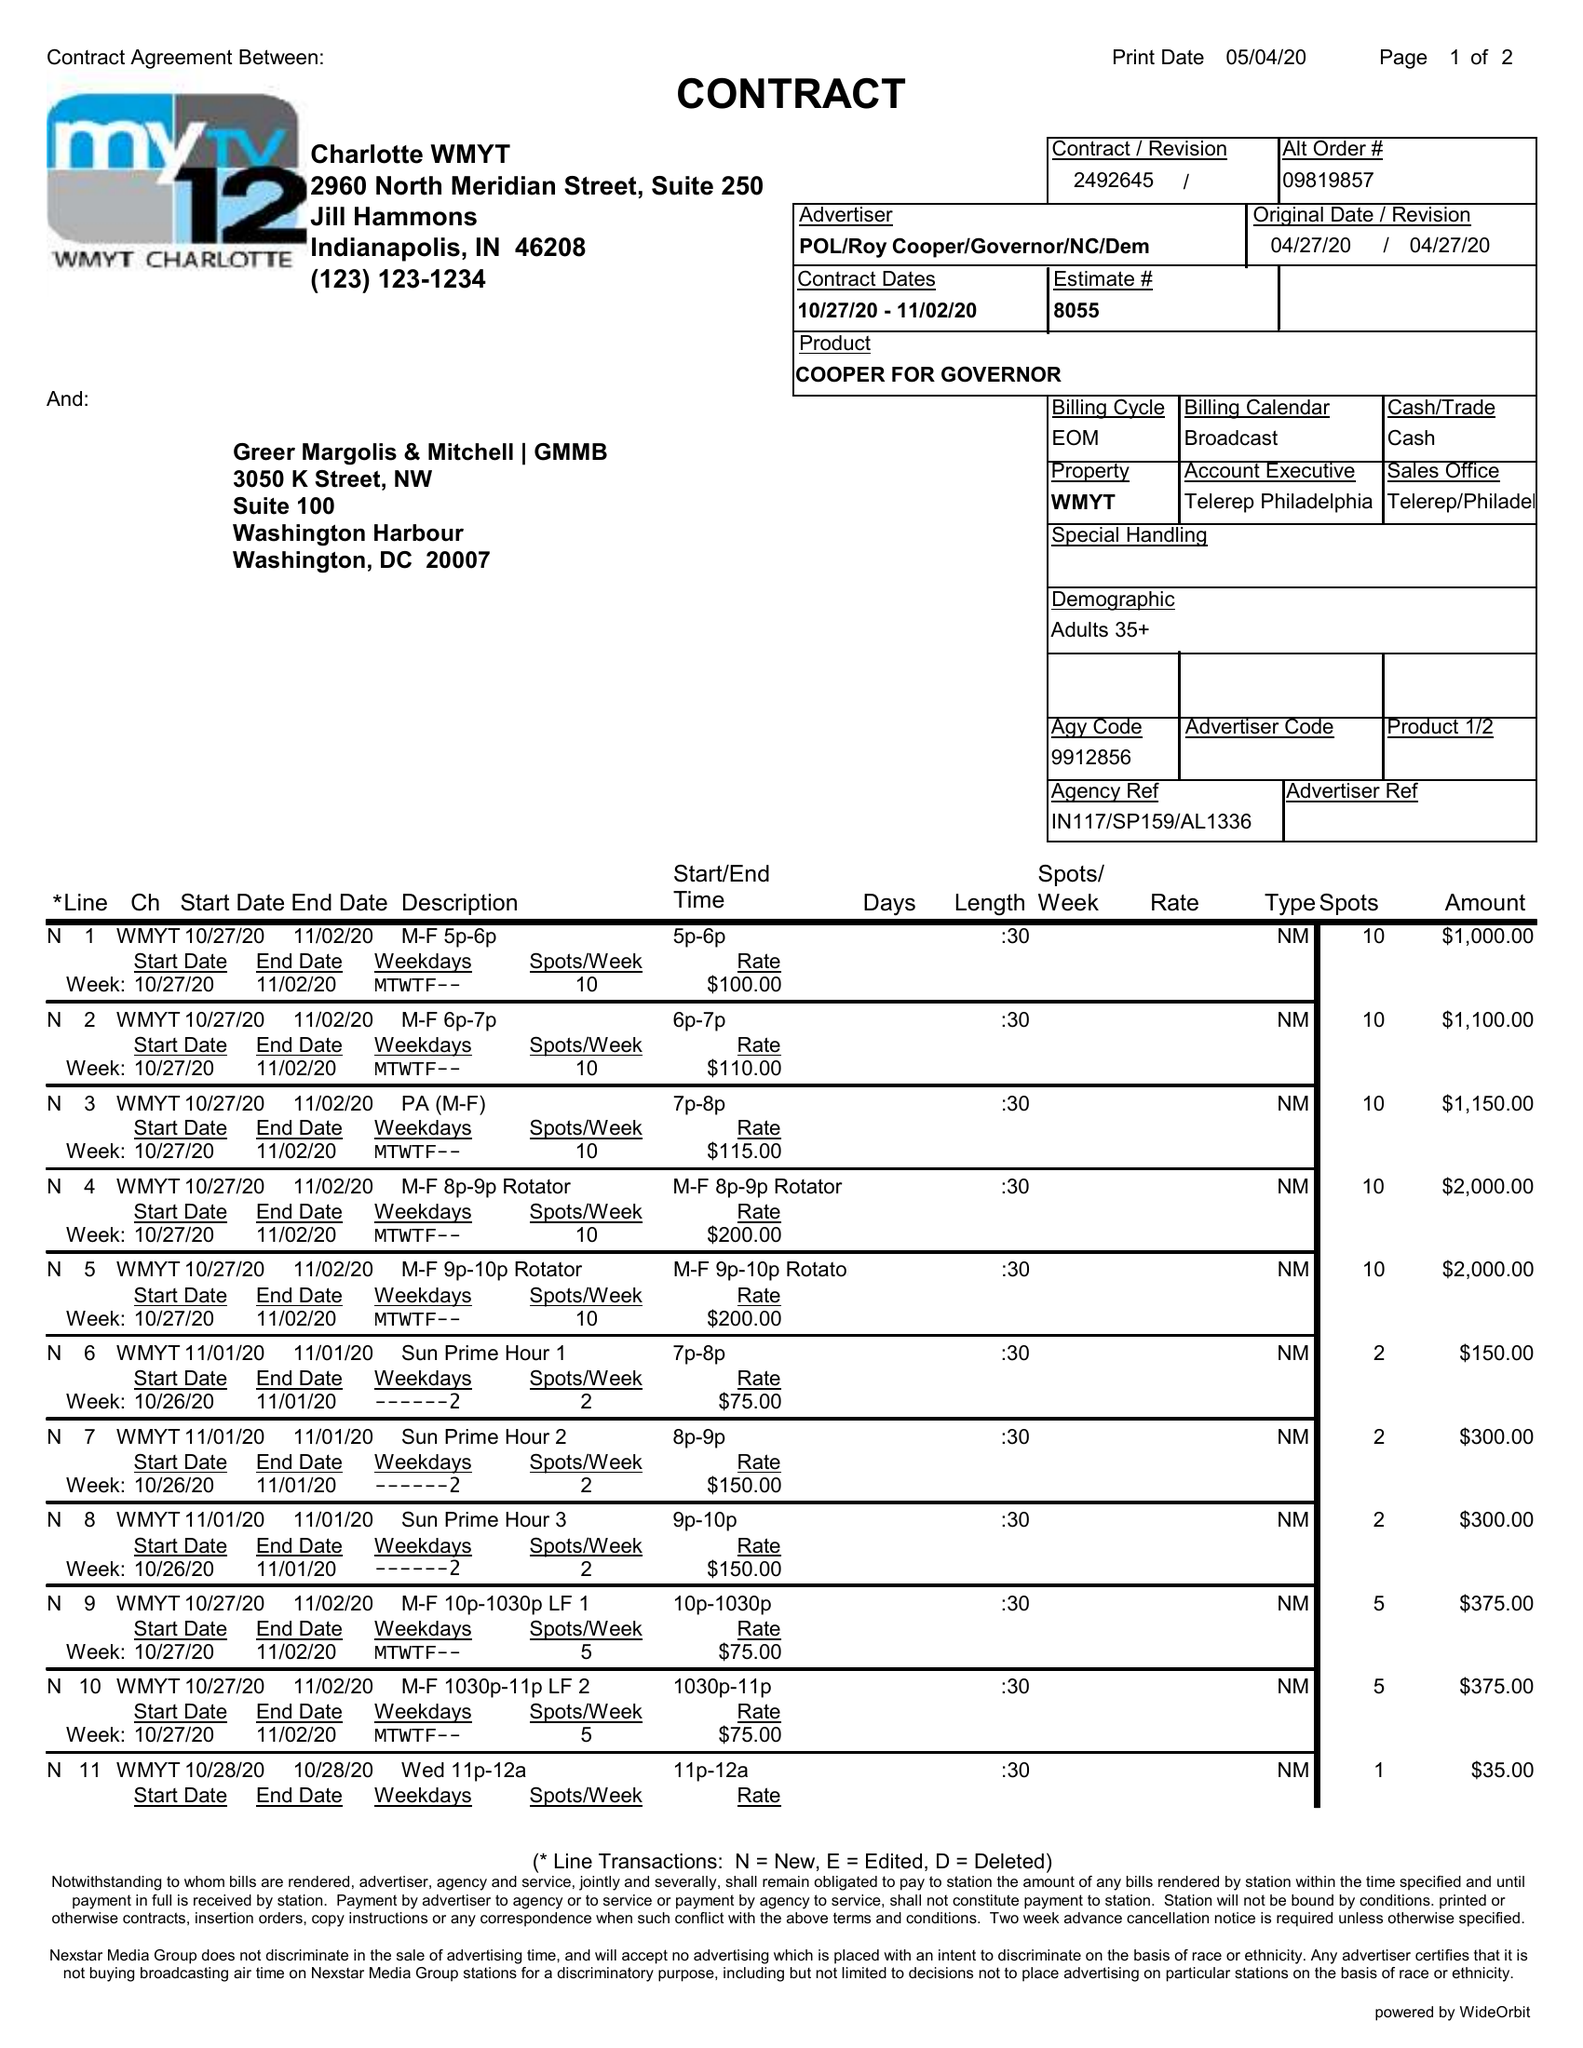What is the value for the contract_num?
Answer the question using a single word or phrase. 2492645 